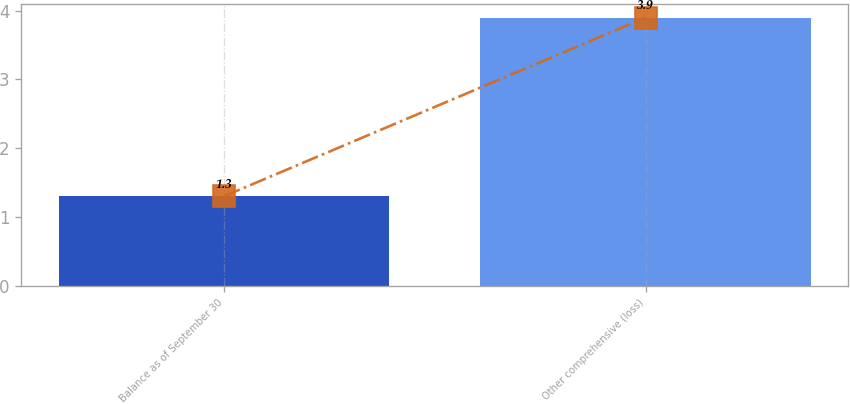<chart> <loc_0><loc_0><loc_500><loc_500><bar_chart><fcel>Balance as of September 30<fcel>Other comprehensive (loss)<nl><fcel>1.3<fcel>3.9<nl></chart> 